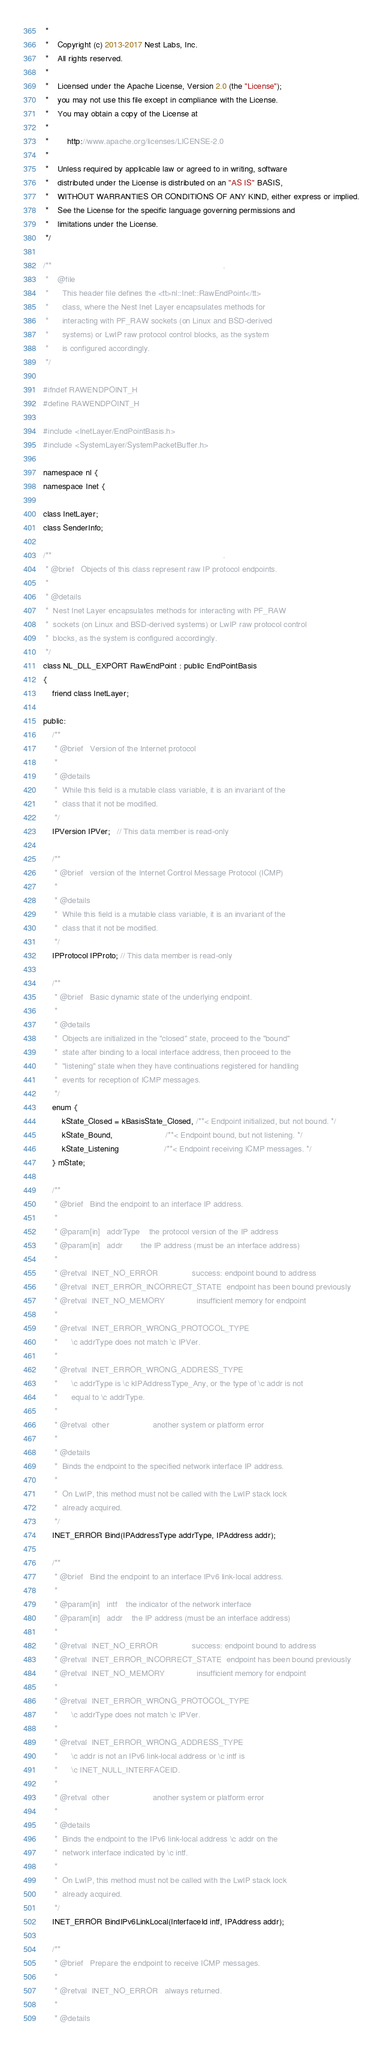<code> <loc_0><loc_0><loc_500><loc_500><_C_> *
 *    Copyright (c) 2013-2017 Nest Labs, Inc.
 *    All rights reserved.
 *
 *    Licensed under the Apache License, Version 2.0 (the "License");
 *    you may not use this file except in compliance with the License.
 *    You may obtain a copy of the License at
 *
 *        http://www.apache.org/licenses/LICENSE-2.0
 *
 *    Unless required by applicable law or agreed to in writing, software
 *    distributed under the License is distributed on an "AS IS" BASIS,
 *    WITHOUT WARRANTIES OR CONDITIONS OF ANY KIND, either express or implied.
 *    See the License for the specific language governing permissions and
 *    limitations under the License.
 */

/**                                                                           .
 *    @file
 *      This header file defines the <tt>nl::Inet::RawEndPoint</tt>
 *      class, where the Nest Inet Layer encapsulates methods for
 *      interacting with PF_RAW sockets (on Linux and BSD-derived
 *      systems) or LwIP raw protocol control blocks, as the system
 *      is configured accordingly.
 */

#ifndef RAWENDPOINT_H
#define RAWENDPOINT_H

#include <InetLayer/EndPointBasis.h>
#include <SystemLayer/SystemPacketBuffer.h>

namespace nl {
namespace Inet {

class InetLayer;
class SenderInfo;

/**                                                                           .
 * @brief   Objects of this class represent raw IP protocol endpoints.
 *
 * @details
 *  Nest Inet Layer encapsulates methods for interacting with PF_RAW
 *  sockets (on Linux and BSD-derived systems) or LwIP raw protocol control
 *  blocks, as the system is configured accordingly.
 */
class NL_DLL_EXPORT RawEndPoint : public EndPointBasis
{
    friend class InetLayer;

public:
    /**
     * @brief   Version of the Internet protocol
     *
     * @details
     *  While this field is a mutable class variable, it is an invariant of the
     *  class that it not be modified.
     */
    IPVersion IPVer;   // This data member is read-only

    /**
     * @brief   version of the Internet Control Message Protocol (ICMP)
     *
     * @details
     *  While this field is a mutable class variable, it is an invariant of the
     *  class that it not be modified.
     */
    IPProtocol IPProto; // This data member is read-only

    /**
     * @brief   Basic dynamic state of the underlying endpoint.
     *
     * @details
     *  Objects are initialized in the "closed" state, proceed to the "bound"
     *  state after binding to a local interface address, then proceed to the
     *  "listening" state when they have continuations registered for handling
     *  events for reception of ICMP messages.
     */
    enum {
        kState_Closed = kBasisState_Closed, /**< Endpoint initialized, but not bound. */
        kState_Bound,                       /**< Endpoint bound, but not listening. */
        kState_Listening                    /**< Endpoint receiving ICMP messages. */
    } mState;

    /**
     * @brief   Bind the endpoint to an interface IP address.
     *
     * @param[in]   addrType    the protocol version of the IP address
     * @param[in]   addr        the IP address (must be an interface address)
     *
     * @retval  INET_NO_ERROR               success: endpoint bound to address
     * @retval  INET_ERROR_INCORRECT_STATE  endpoint has been bound previously
     * @retval  INET_NO_MEMORY              insufficient memory for endpoint
     *
     * @retval  INET_ERROR_WRONG_PROTOCOL_TYPE
     *      \c addrType does not match \c IPVer.
     *
     * @retval  INET_ERROR_WRONG_ADDRESS_TYPE
     *      \c addrType is \c kIPAddressType_Any, or the type of \c addr is not
     *      equal to \c addrType.
     *
     * @retval  other                   another system or platform error
     *
     * @details
     *  Binds the endpoint to the specified network interface IP address.
     *
     *  On LwIP, this method must not be called with the LwIP stack lock
     *  already acquired.
     */
    INET_ERROR Bind(IPAddressType addrType, IPAddress addr);

    /**
     * @brief   Bind the endpoint to an interface IPv6 link-local address.
     *
     * @param[in]   intf    the indicator of the network interface
     * @param[in]   addr    the IP address (must be an interface address)
     *
     * @retval  INET_NO_ERROR               success: endpoint bound to address
     * @retval  INET_ERROR_INCORRECT_STATE  endpoint has been bound previously
     * @retval  INET_NO_MEMORY              insufficient memory for endpoint
     *
     * @retval  INET_ERROR_WRONG_PROTOCOL_TYPE
     *      \c addrType does not match \c IPVer.
     *
     * @retval  INET_ERROR_WRONG_ADDRESS_TYPE
     *      \c addr is not an IPv6 link-local address or \c intf is
     *      \c INET_NULL_INTERFACEID.
     *
     * @retval  other                   another system or platform error
     *
     * @details
     *  Binds the endpoint to the IPv6 link-local address \c addr on the
     *  network interface indicated by \c intf.
     *
     *  On LwIP, this method must not be called with the LwIP stack lock
     *  already acquired.
     */
    INET_ERROR BindIPv6LinkLocal(InterfaceId intf, IPAddress addr);

    /**
     * @brief   Prepare the endpoint to receive ICMP messages.
     *
     * @retval  INET_NO_ERROR   always returned.
     *
     * @details</code> 